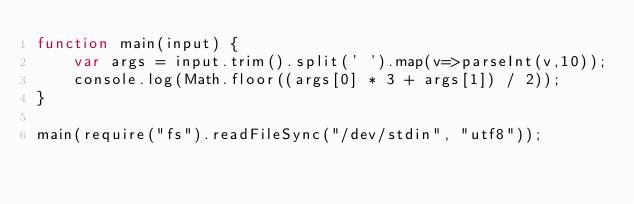Convert code to text. <code><loc_0><loc_0><loc_500><loc_500><_JavaScript_>function main(input) {
    var args = input.trim().split(' ').map(v=>parseInt(v,10));
    console.log(Math.floor((args[0] * 3 + args[1]) / 2));
}
 
main(require("fs").readFileSync("/dev/stdin", "utf8"));</code> 